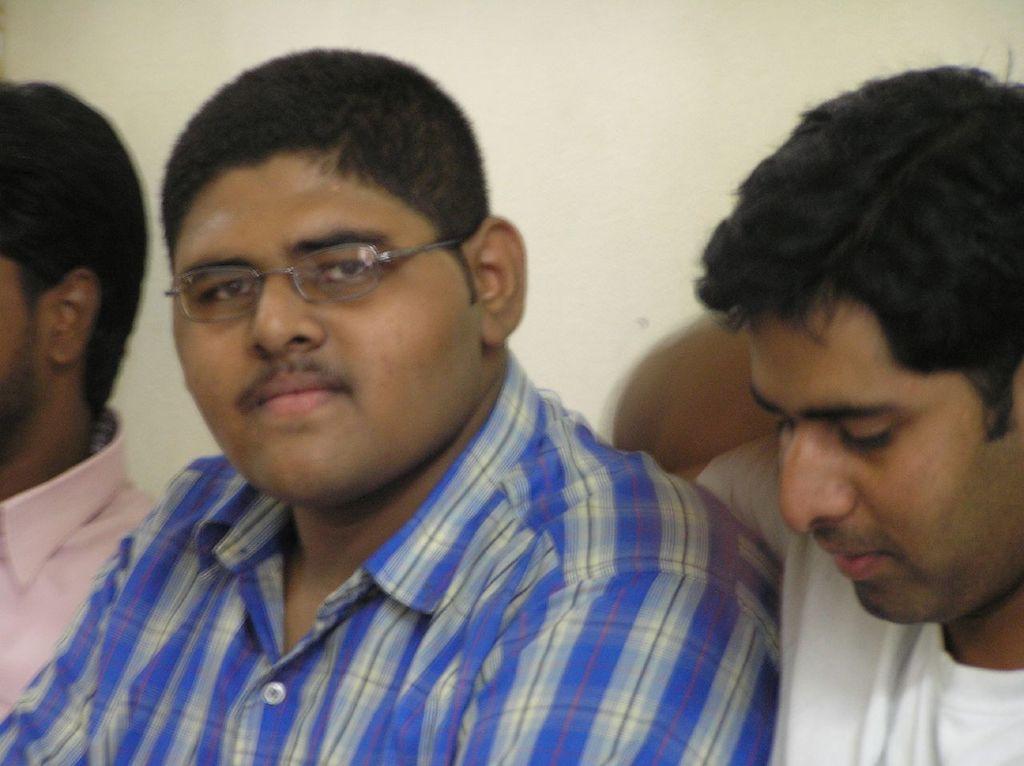Can you describe this image briefly? In this image we can see three persons, among them one person is wearing spectacles and in the background we can see the wall. 